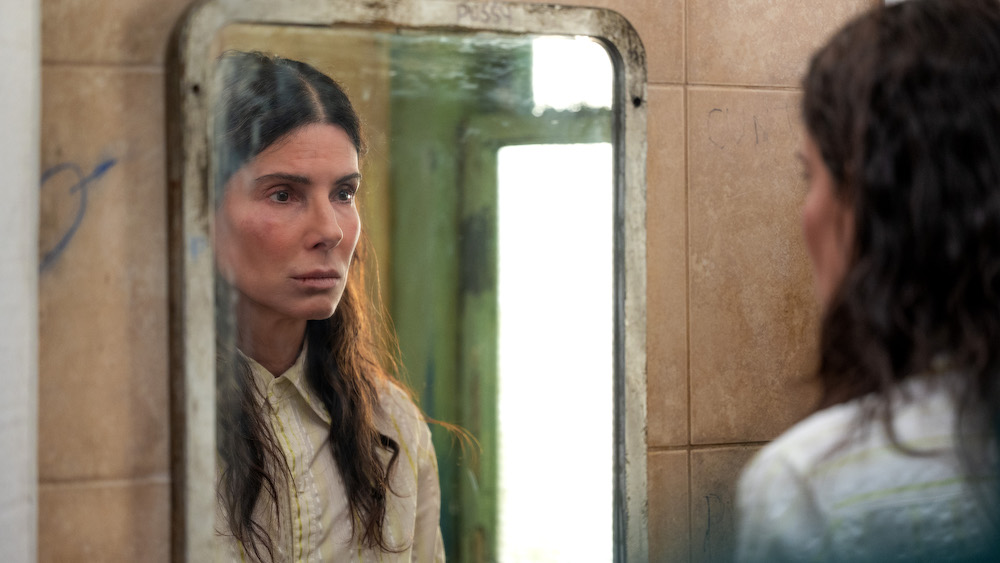What emotions are conveyed by this scene? The scene conveys a sense of introspection and somber reflection. The woman's serious expression as she gazes at herself in the mirror suggests that she is deep in thought, possibly contemplating an important decision or dealing with inner turmoil. The dilapidated state of the bathroom, combined with the graffiti on the walls, adds a layer of despair and abandonment. What could have happened here to make this bathroom fall into such disrepair? There could be many reasons for the bathroom's current state of disrepair. It might be in an abandoned building that has been left neglected for a long time. Perhaps the building was once a thriving place, but economic downturns or disasters led to its abandonment. Alternatively, it could be a site frequently visited by people in desperate situations, leading to its current dilapidated state. The graffiti on the walls suggests a history of occupancy and a lack of maintenance. If the woman could speak to her reflection, what do you think she might say? "What have I become? Is this what I wanted for my life?" She might be questioning her past decisions, searching for a way to reconcile her current situation with her aspirations. The depth of her gaze hints at a profound internal dialogue, possibly filled with regret, reflection, or even a steely determination to change her course. Imagine she finds a hidden message behind the mirror. What could it say? The message could be a cryptic yet poignant reminder of hope or a clue to a mystery hidden within the walls. It might say something like, "In the darkest times, even a glimmer of light can show the way." This could serve as a motivator for her to find her way out of whatever difficult situation she finds herself in. 